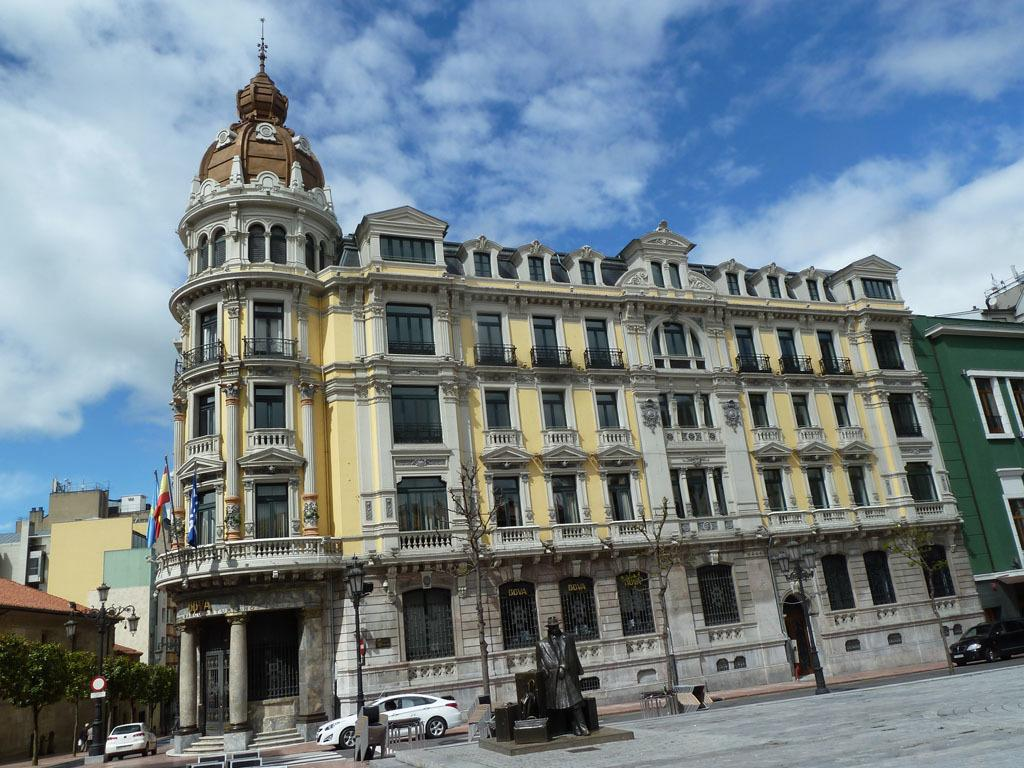What type of structure is visible in the picture? There is a building in the picture. What feature can be seen on the building? The building has windows. What can be found on the left side of the picture? There are trees on the left side of the picture. What pathway is present in the picture? There is a walkway in the picture. What type of decorative objects are in the picture? There are statues in the picture. What is the condition of the sky in the picture? The sky is clear in the picture. Where is the shelf located in the picture? There is no shelf present in the picture. What type of base is supporting the building in the picture? The building is not shown to be supported by any base in the picture. 